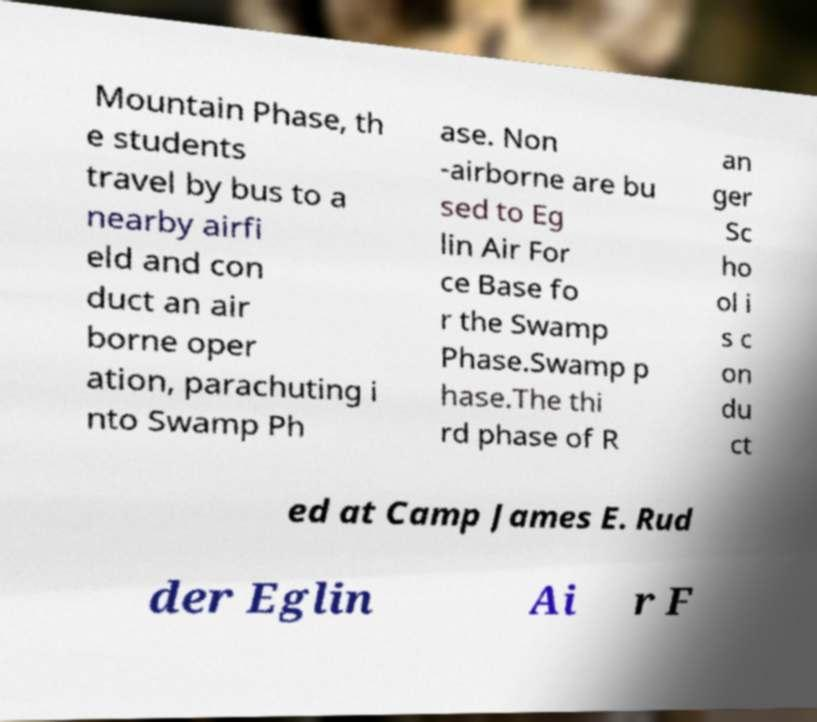Can you read and provide the text displayed in the image?This photo seems to have some interesting text. Can you extract and type it out for me? Mountain Phase, th e students travel by bus to a nearby airfi eld and con duct an air borne oper ation, parachuting i nto Swamp Ph ase. Non -airborne are bu sed to Eg lin Air For ce Base fo r the Swamp Phase.Swamp p hase.The thi rd phase of R an ger Sc ho ol i s c on du ct ed at Camp James E. Rud der Eglin Ai r F 